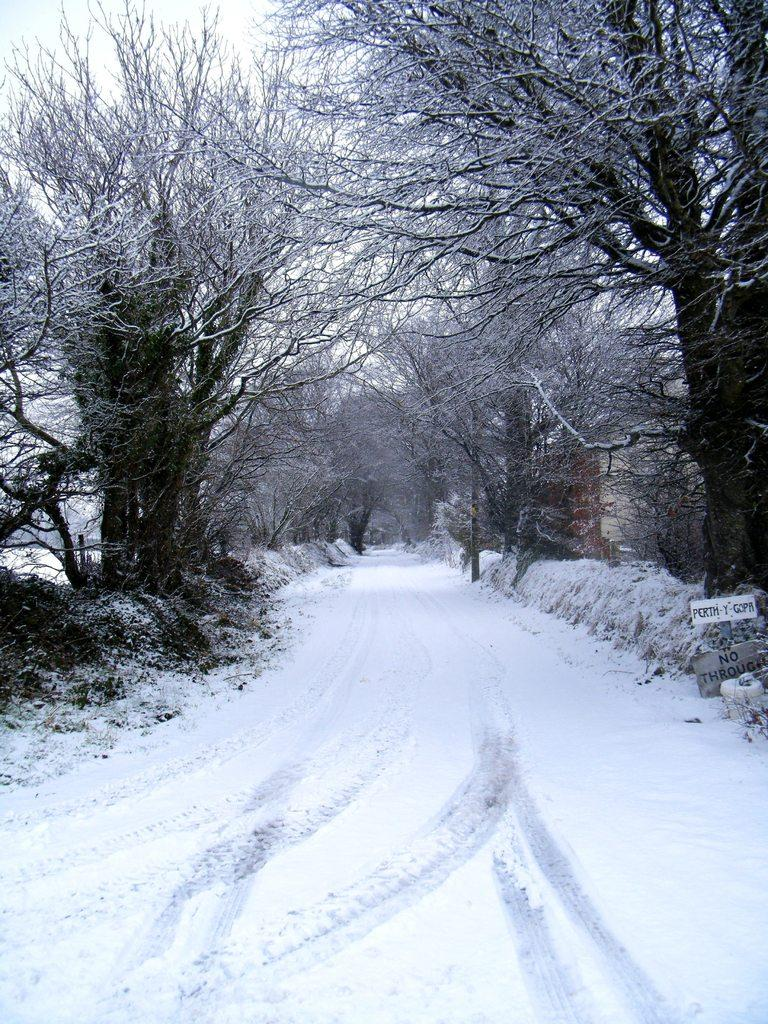What type of vegetation can be seen in the image? There are trees in the image. What is the weather like in the image? There is snow in the image, indicating a cold and snowy environment. What equipment is visible in the image? There are skis and boards in the image. What is written on the boards? Something is written on the boards, but the specific message cannot be determined from the image. How is the land depicted in the image? The land is covered with snow. Can you see any chickens in the image? There are no chickens present in the image. What type of jeans are the people wearing in the image? There are no people visible in the image, so it is impossible to determine what type of jeans they might be wearing. 